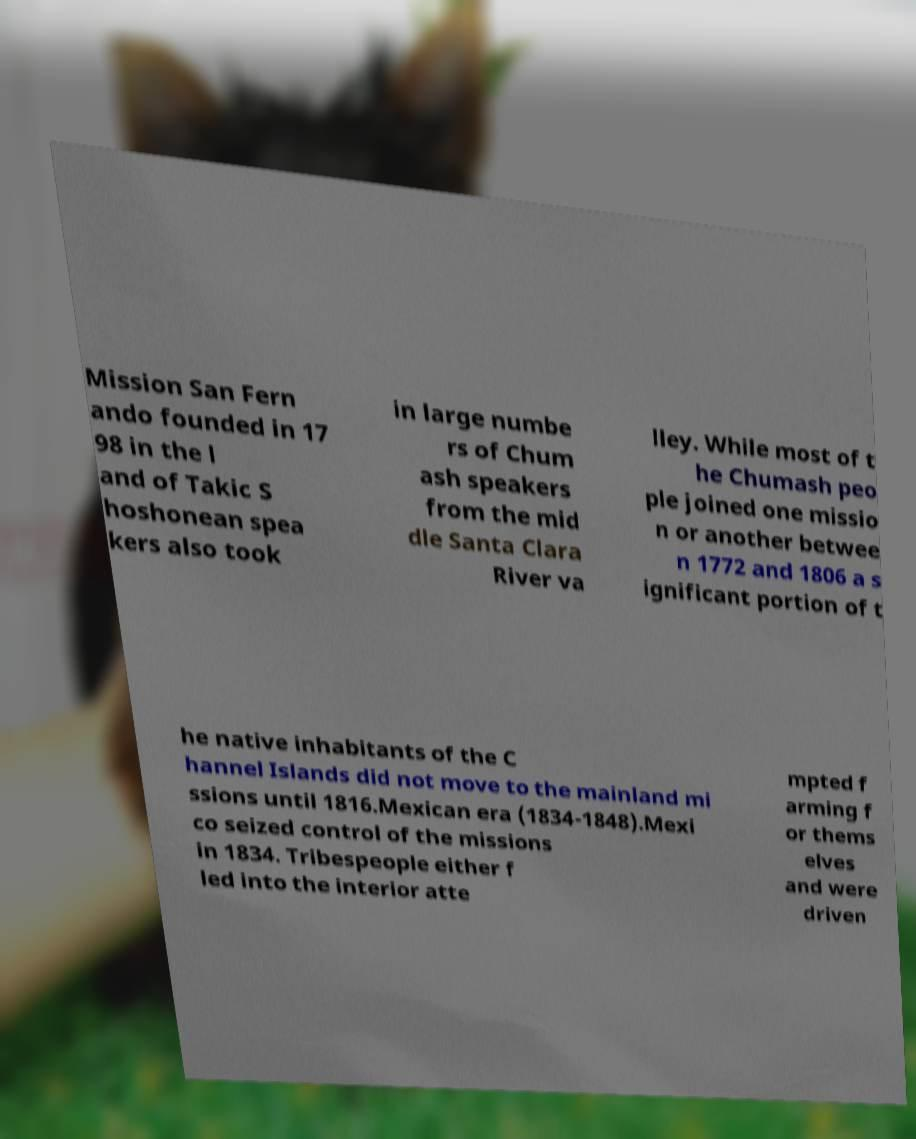Can you accurately transcribe the text from the provided image for me? Mission San Fern ando founded in 17 98 in the l and of Takic S hoshonean spea kers also took in large numbe rs of Chum ash speakers from the mid dle Santa Clara River va lley. While most of t he Chumash peo ple joined one missio n or another betwee n 1772 and 1806 a s ignificant portion of t he native inhabitants of the C hannel Islands did not move to the mainland mi ssions until 1816.Mexican era (1834-1848).Mexi co seized control of the missions in 1834. Tribespeople either f led into the interior atte mpted f arming f or thems elves and were driven 